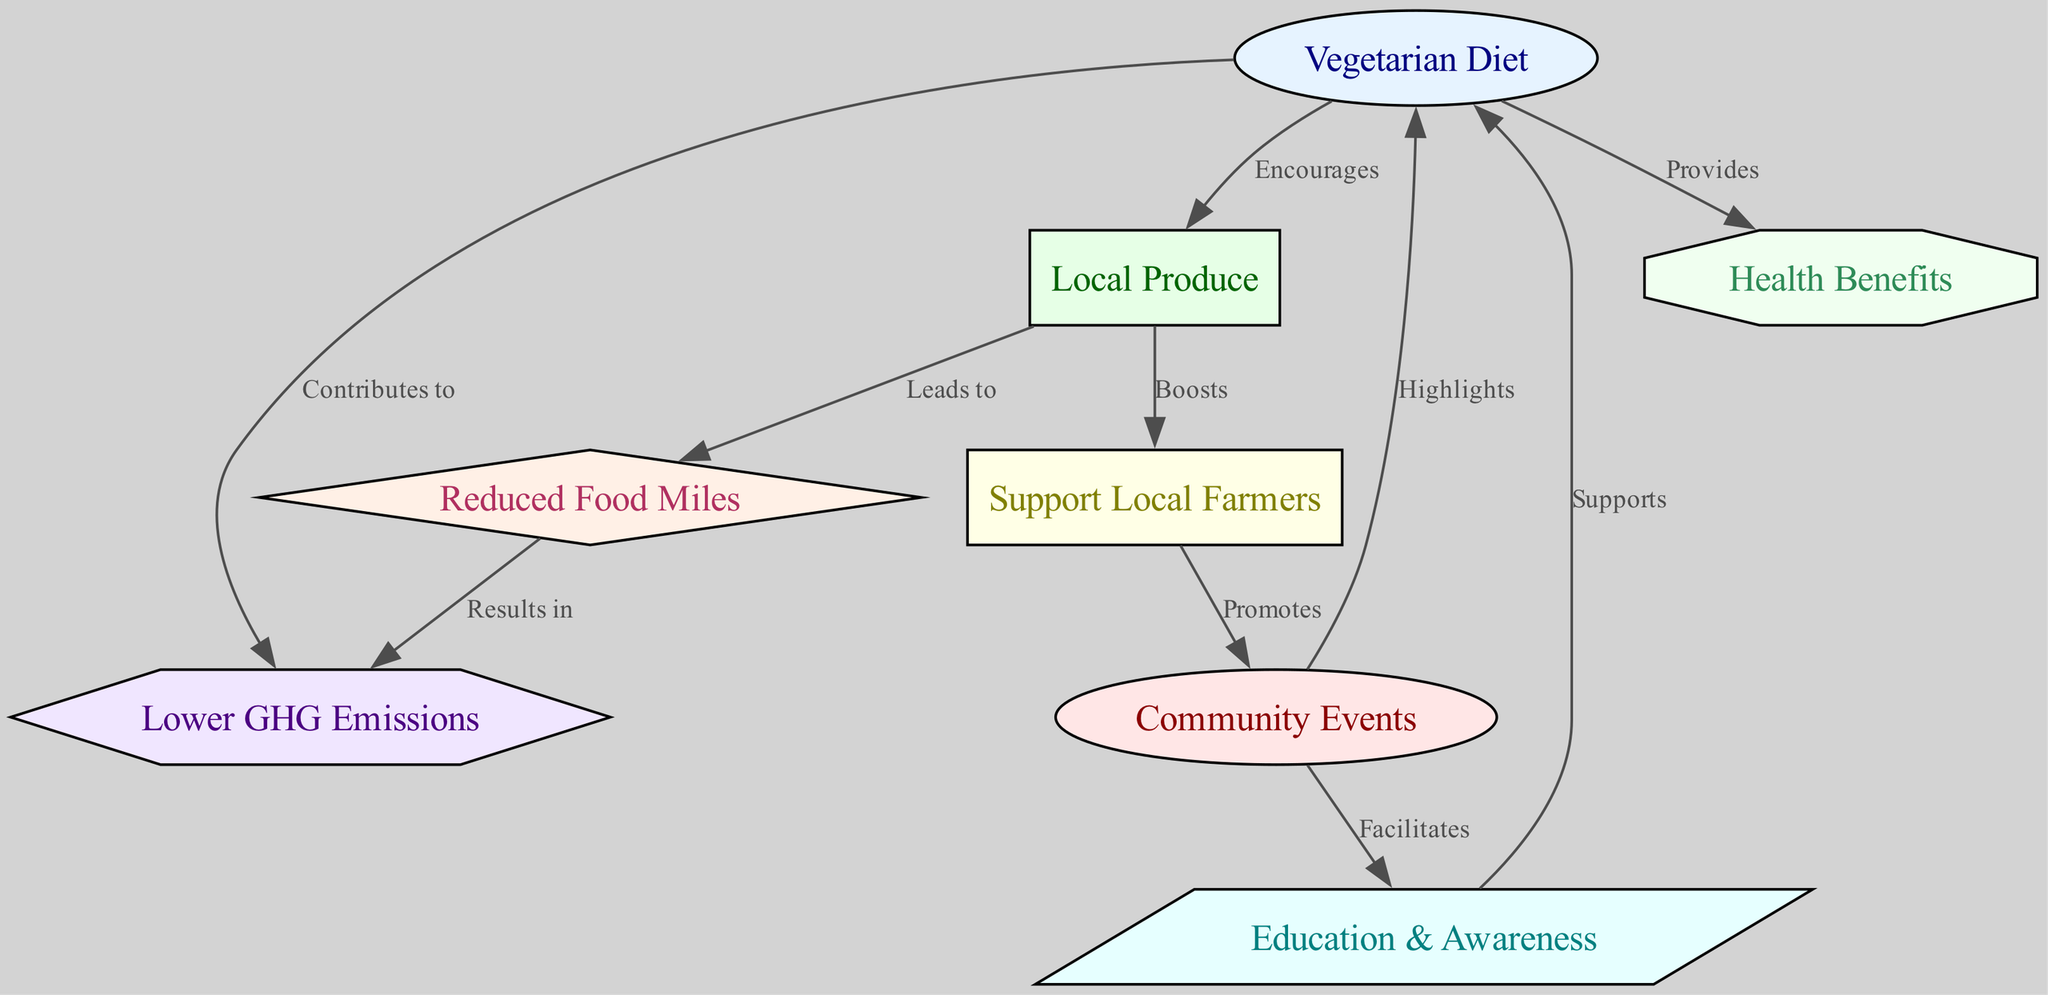What is the central topic of the diagram? The diagram focuses on the "Vegetarian Diet" as the central topic, indicated by its central position and connections to other nodes.
Answer: Vegetarian Diet How many nodes are present in the diagram? Counting the nodes listed, there are a total of eight distinct nodes present in the diagram.
Answer: Eight What does "Vegetarian Diet" encourage according to the diagram? The diagram shows that the "Vegetarian Diet" encourages the use of "Local Produce," as indicated by the edge labeled "Encourages" connecting these nodes.
Answer: Local Produce Which node is connected to "Support Local Farmers"? The node directly linked to "Support Local Farmers" is "Local Produce," which boosts the support as per the labeled edge in the diagram.
Answer: Local Produce What is the result of "Reduced Food Miles" in the context of the diagram? The diagram illustrates that "Reduced Food Miles" results in "Lower GHG Emissions," as shown by the edge connecting these two nodes with the label "Results in."
Answer: Lower GHG Emissions How does "Community Events" relate to "Education Awareness"? The connection shows that "Community Events" facilitates "Education & Awareness," as indicated by the edge labeled "Facilitates."
Answer: Facilitates What does "Education & Awareness" support according to the diagram? The flow in the diagram indicates that "Education & Awareness" supports "Vegetarian Diet," illustrated by the edge labeled "Supports."
Answer: Vegetarian Diet What benefits does the vegetarian diet provide? The diagram highlights that the vegetarian diet provides "Health Benefits," connected directly to the "Vegetarian Diet" node.
Answer: Health Benefits How does supporting local farmers impact community initiatives? Supporting local farmers promotes "Community Events," as indicated by the labeled edge connecting these nodes which demonstrates the community impact.
Answer: Promotes 